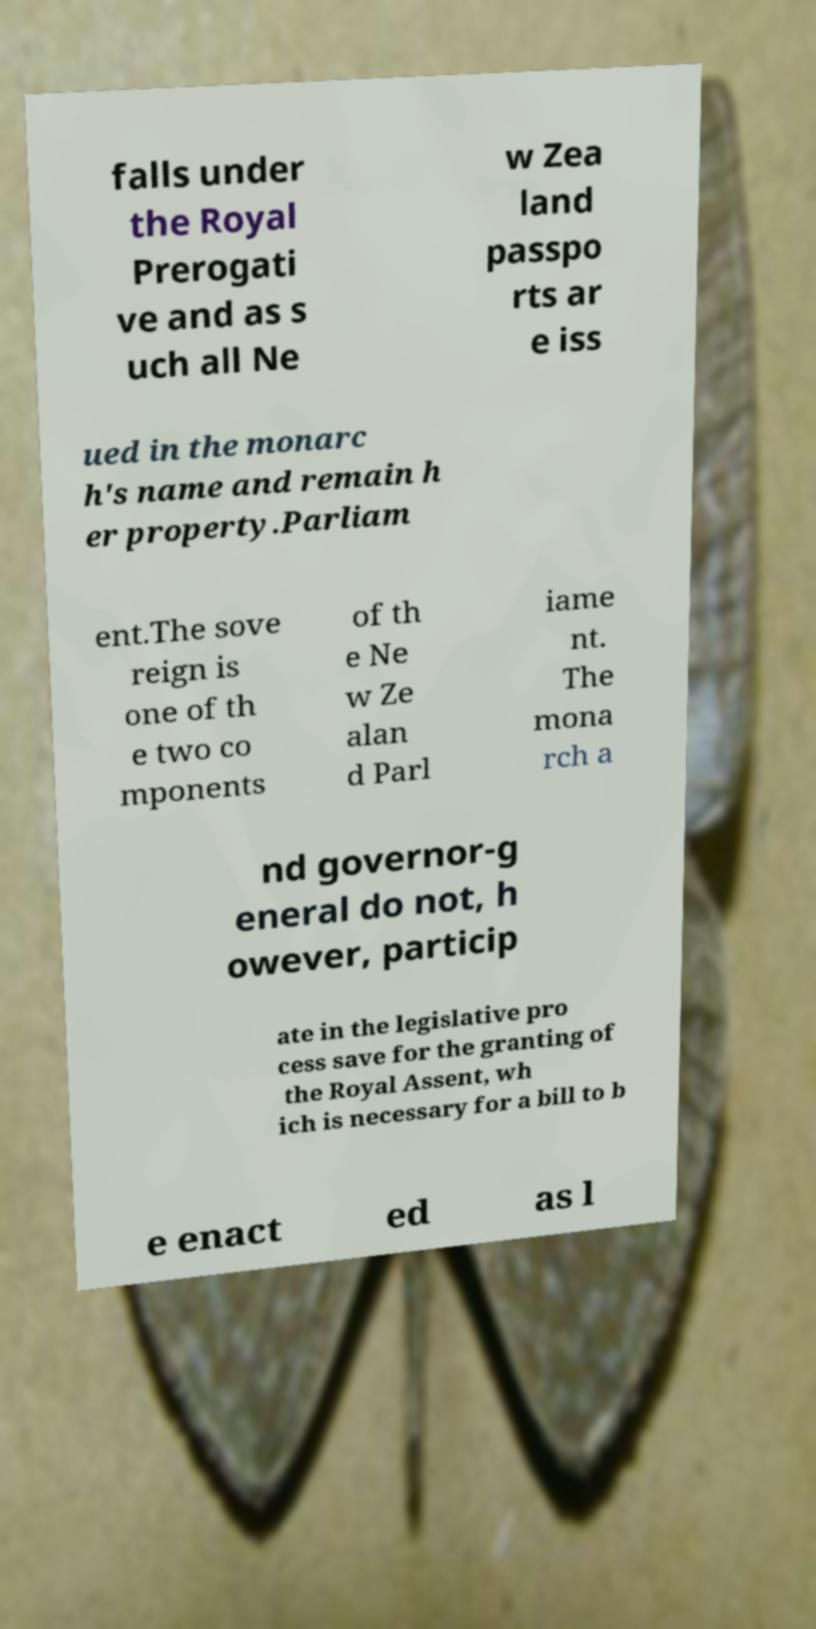Please identify and transcribe the text found in this image. falls under the Royal Prerogati ve and as s uch all Ne w Zea land passpo rts ar e iss ued in the monarc h's name and remain h er property.Parliam ent.The sove reign is one of th e two co mponents of th e Ne w Ze alan d Parl iame nt. The mona rch a nd governor-g eneral do not, h owever, particip ate in the legislative pro cess save for the granting of the Royal Assent, wh ich is necessary for a bill to b e enact ed as l 